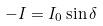<formula> <loc_0><loc_0><loc_500><loc_500>- I = I _ { 0 } \sin \delta</formula> 